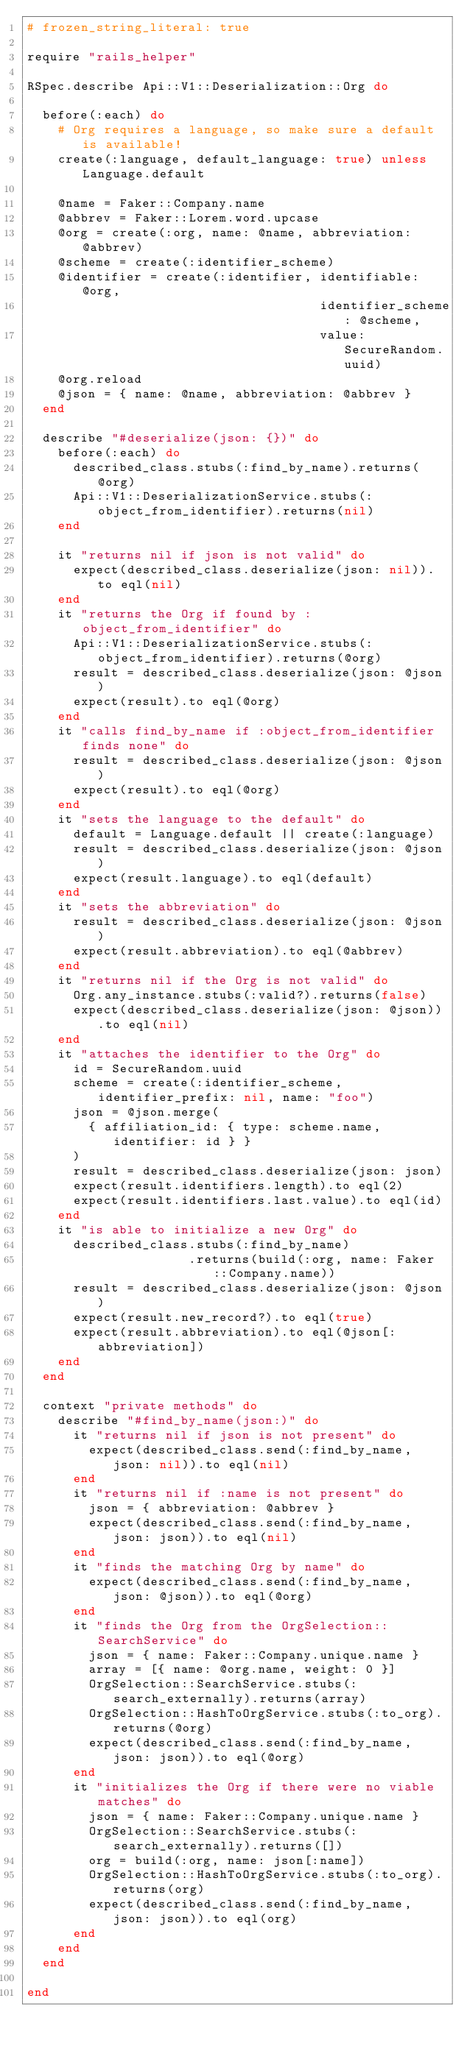Convert code to text. <code><loc_0><loc_0><loc_500><loc_500><_Ruby_># frozen_string_literal: true

require "rails_helper"

RSpec.describe Api::V1::Deserialization::Org do

  before(:each) do
    # Org requires a language, so make sure a default is available!
    create(:language, default_language: true) unless Language.default

    @name = Faker::Company.name
    @abbrev = Faker::Lorem.word.upcase
    @org = create(:org, name: @name, abbreviation: @abbrev)
    @scheme = create(:identifier_scheme)
    @identifier = create(:identifier, identifiable: @org,
                                      identifier_scheme: @scheme,
                                      value: SecureRandom.uuid)
    @org.reload
    @json = { name: @name, abbreviation: @abbrev }
  end

  describe "#deserialize(json: {})" do
    before(:each) do
      described_class.stubs(:find_by_name).returns(@org)
      Api::V1::DeserializationService.stubs(:object_from_identifier).returns(nil)
    end

    it "returns nil if json is not valid" do
      expect(described_class.deserialize(json: nil)).to eql(nil)
    end
    it "returns the Org if found by :object_from_identifier" do
      Api::V1::DeserializationService.stubs(:object_from_identifier).returns(@org)
      result = described_class.deserialize(json: @json)
      expect(result).to eql(@org)
    end
    it "calls find_by_name if :object_from_identifier finds none" do
      result = described_class.deserialize(json: @json)
      expect(result).to eql(@org)
    end
    it "sets the language to the default" do
      default = Language.default || create(:language)
      result = described_class.deserialize(json: @json)
      expect(result.language).to eql(default)
    end
    it "sets the abbreviation" do
      result = described_class.deserialize(json: @json)
      expect(result.abbreviation).to eql(@abbrev)
    end
    it "returns nil if the Org is not valid" do
      Org.any_instance.stubs(:valid?).returns(false)
      expect(described_class.deserialize(json: @json)).to eql(nil)
    end
    it "attaches the identifier to the Org" do
      id = SecureRandom.uuid
      scheme = create(:identifier_scheme, identifier_prefix: nil, name: "foo")
      json = @json.merge(
        { affiliation_id: { type: scheme.name, identifier: id } }
      )
      result = described_class.deserialize(json: json)
      expect(result.identifiers.length).to eql(2)
      expect(result.identifiers.last.value).to eql(id)
    end
    it "is able to initialize a new Org" do
      described_class.stubs(:find_by_name)
                     .returns(build(:org, name: Faker::Company.name))
      result = described_class.deserialize(json: @json)
      expect(result.new_record?).to eql(true)
      expect(result.abbreviation).to eql(@json[:abbreviation])
    end
  end

  context "private methods" do
    describe "#find_by_name(json:)" do
      it "returns nil if json is not present" do
        expect(described_class.send(:find_by_name, json: nil)).to eql(nil)
      end
      it "returns nil if :name is not present" do
        json = { abbreviation: @abbrev }
        expect(described_class.send(:find_by_name, json: json)).to eql(nil)
      end
      it "finds the matching Org by name" do
        expect(described_class.send(:find_by_name, json: @json)).to eql(@org)
      end
      it "finds the Org from the OrgSelection::SearchService" do
        json = { name: Faker::Company.unique.name }
        array = [{ name: @org.name, weight: 0 }]
        OrgSelection::SearchService.stubs(:search_externally).returns(array)
        OrgSelection::HashToOrgService.stubs(:to_org).returns(@org)
        expect(described_class.send(:find_by_name, json: json)).to eql(@org)
      end
      it "initializes the Org if there were no viable matches" do
        json = { name: Faker::Company.unique.name }
        OrgSelection::SearchService.stubs(:search_externally).returns([])
        org = build(:org, name: json[:name])
        OrgSelection::HashToOrgService.stubs(:to_org).returns(org)
        expect(described_class.send(:find_by_name, json: json)).to eql(org)
      end
    end
  end

end
</code> 